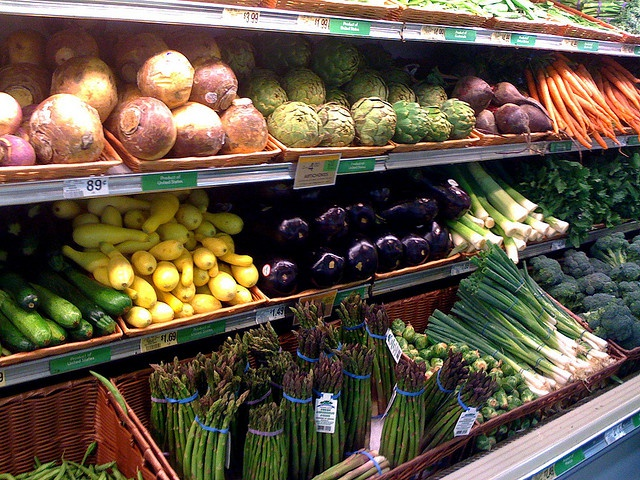Describe the objects in this image and their specific colors. I can see carrot in lightgray, maroon, black, and salmon tones, broccoli in lightgray, gray, black, blue, and navy tones, broccoli in lightgray, black, teal, and darkgreen tones, broccoli in lightgray, gray, black, purple, and darkgreen tones, and carrot in lightgray, red, salmon, and brown tones in this image. 